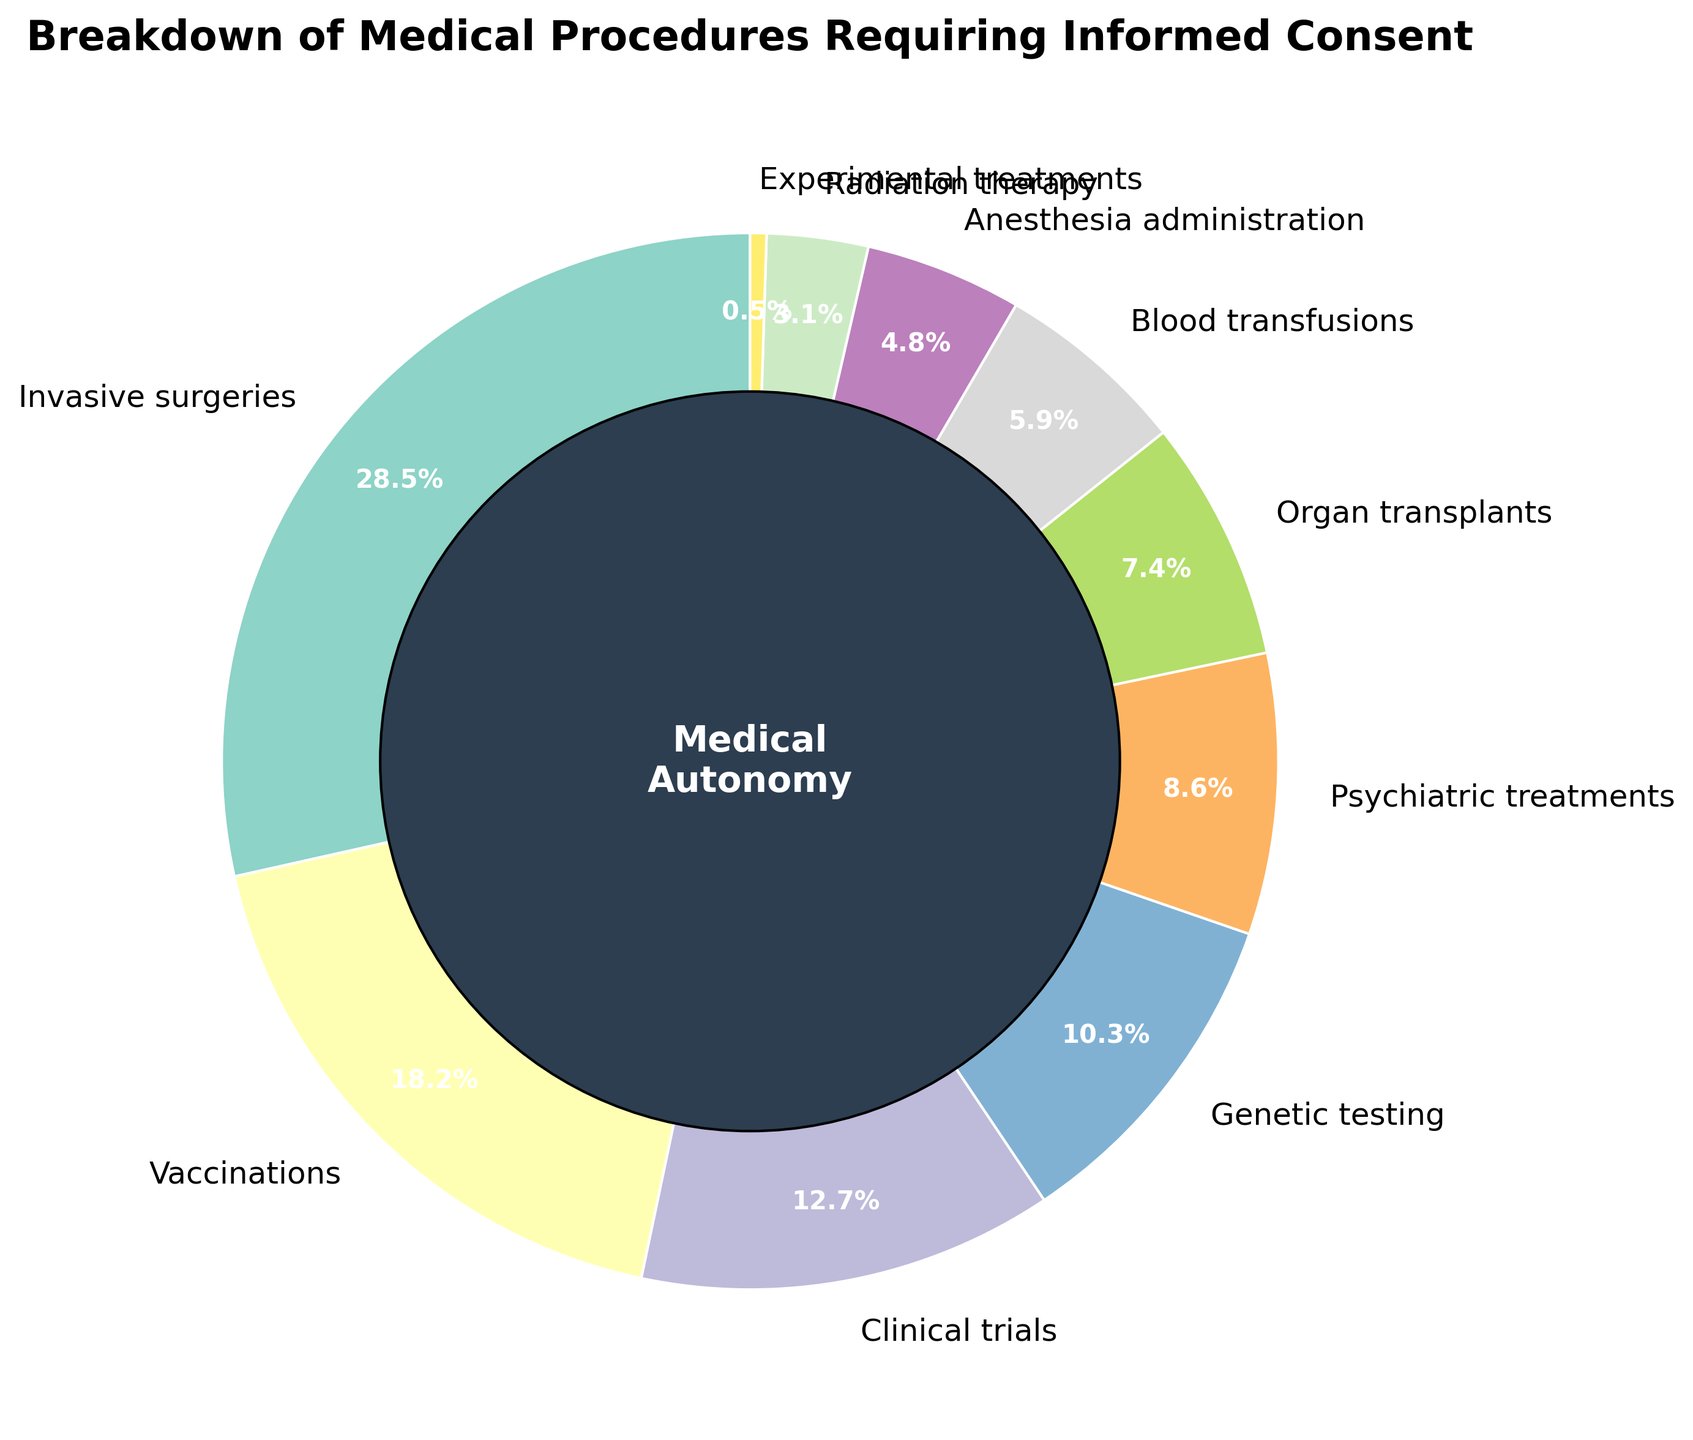What medical procedure category has the highest percentage? The figure shows that "Invasive surgeries" section is the largest. The percentage for "Invasive surgeries" is 28.5%.
Answer: Invasive surgeries What two categories combined make up more than 50% of the procedures requiring informed consent? The categories "Invasive surgeries" and "Vaccinations" can be combined. Their percentages are 28.5% and 18.2%, respectively. Adding them together gives 46.7%, which is less. If we sum the next category "Clinical trials", we exceed 50%. So, "Invasive surgeries" and "Vaccinations", and "Clinical trials" combined.
Answer: Invasive surgeries and Vaccinations Which procedure category has nearly the same percentage as Genetic testing and Psychiatric treatments combined? The percentage for Genetic testing is 10.3% and for Psychiatric treatments is 8.6%. Adding these together gives 18.9%, which is close to Vaccinations (18.2%).
Answer: Vaccinations What is the second smallest percentage for the procedure categories? The smallest percentage is 0.5% for Experimental treatments. The next smallest is 3.1% for Radiation therapy.
Answer: Radiation therapy Between "Blood transfusions" and "Anesthesia administration," which one has a higher percentage? The figure shows 5.9% for "Blood transfusions" and 4.8% for "Anesthesia administration." Therefore, "Blood transfusions" have a higher percentage.
Answer: Blood transfusions What is the total percentage of the three smallest procedure categories? The smallest category is "Experimental treatments" with 0.5%, followed by "Radiation therapy" with 3.1%, and "Anesthesia administration" with 4.8%. Adding those together gives 0.5 + 3.1 + 4.8 = 8.4%.
Answer: 8.4% Which category makes up less than 1% of the procedures requiring informed consent? The figure highlights that "Experimental treatments" is the only category with a percentage of 0.5%, which is less than 1%.
Answer: Experimental treatments How many procedure categories contribute more than 10% each? The categories contributing more than 10% each are "Invasive surgeries" (28.5%), "Vaccinations" (18.2%), and "Clinical trials" (12.7%). This makes a total of 3 categories.
Answer: 3 What is the combined percentage for Clinical trials, Psychiatric treatments, and Blood transfusions? The percentages are 12.7% for Clinical trials, 8.6% for Psychiatric treatments, and 5.9% for Blood transfusions. Adding these together gives 12.7 + 8.6 + 5.9 = 27.2%.
Answer: 27.2% What is the most common color used in the plot's wedges, excluding the center circle? The figure uses a diverse palette, but shades of green appear multiple times in different segments such as "Invasive surgeries" and "Genetic testing."
Answer: Green 